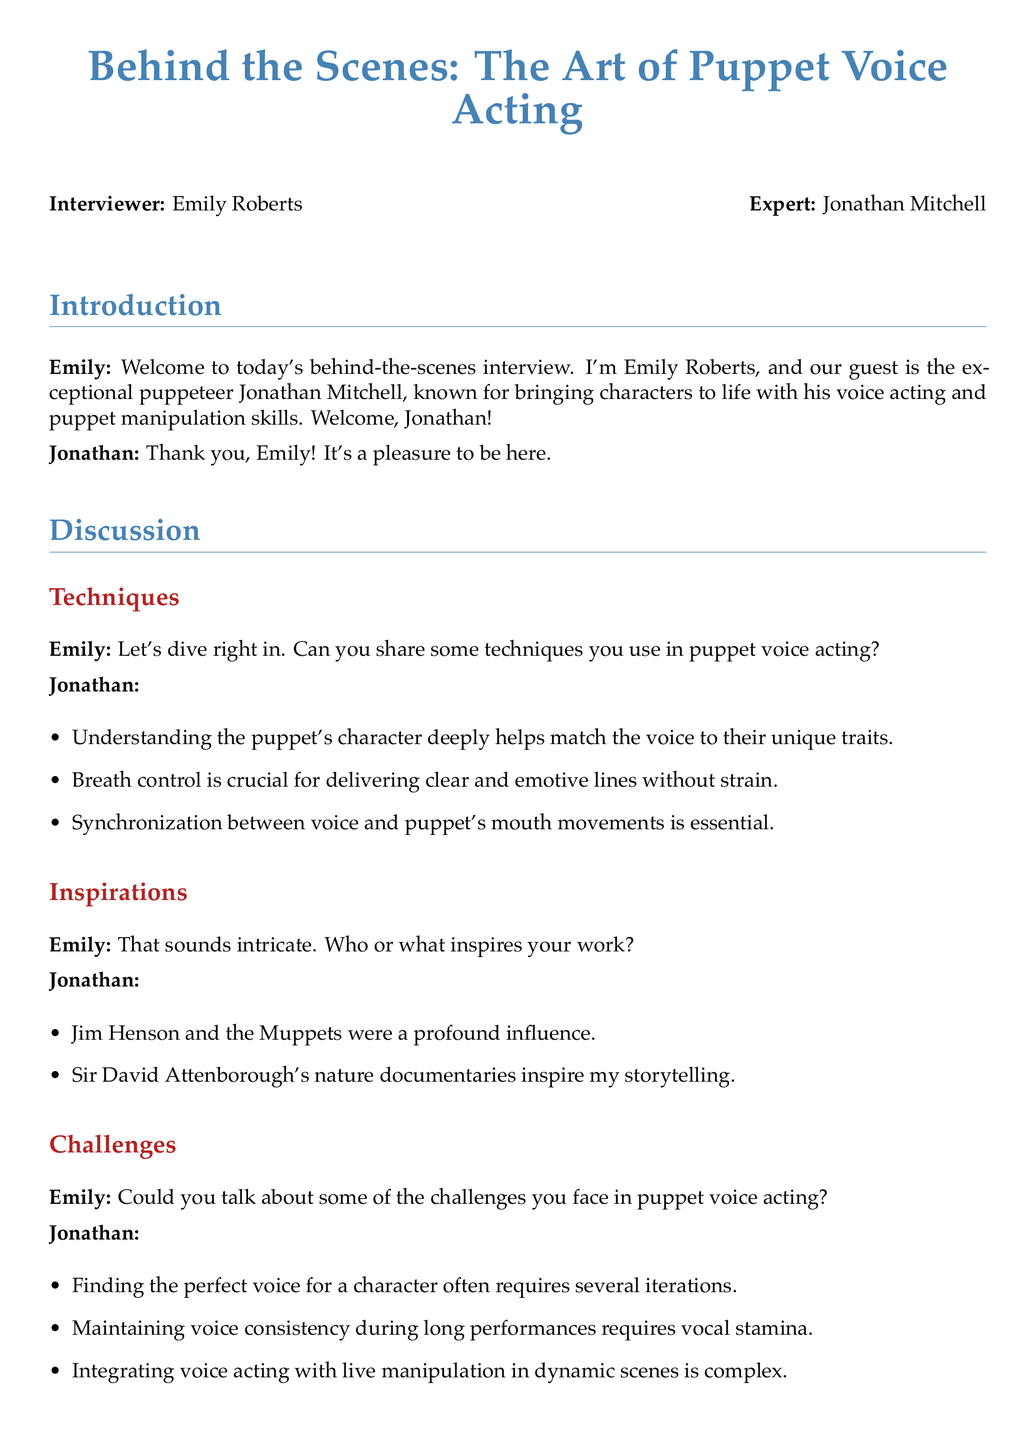What is the name of the interviewer? The interviewer's name is mentioned at the beginning of the document as Emily Roberts.
Answer: Emily Roberts Who is the expert being interviewed? The expert being interviewed is introduced in the document as Jonathan Mitchell.
Answer: Jonathan Mitchell What are the three techniques mentioned for puppet voice acting? The document lists techniques which include understanding the puppet's character, breath control, and synchronization.
Answer: Understanding the puppet's character, breath control, synchronization Name one person who inspired Jonathan's work. The document specifies that Jim Henson is one of the major influences on Jonathan's work.
Answer: Jim Henson What is one challenge mentioned regarding puppet voice acting? The document highlights a challenge about maintaining voice consistency during long performances.
Answer: Maintaining voice consistency during long performances How many inspirations are listed in Jonathan's response? The document states that there are two sources of inspiration in Jonathan's response.
Answer: Two What advice does Jonathan give to aspiring puppeteers? One piece of advice given is to never stop practicing and experimenting with each unique puppet.
Answer: Never stop practicing and experimenting with each unique puppet What is the primary focus of the document? The document's primary focus revolves around the art of puppet voice acting and its nuances.
Answer: Puppet voice acting Who is noted for inspiring storytelling in Jonathan's work? The document names Sir David Attenborough for inspiring Jonathan's storytelling.
Answer: Sir David Attenborough 